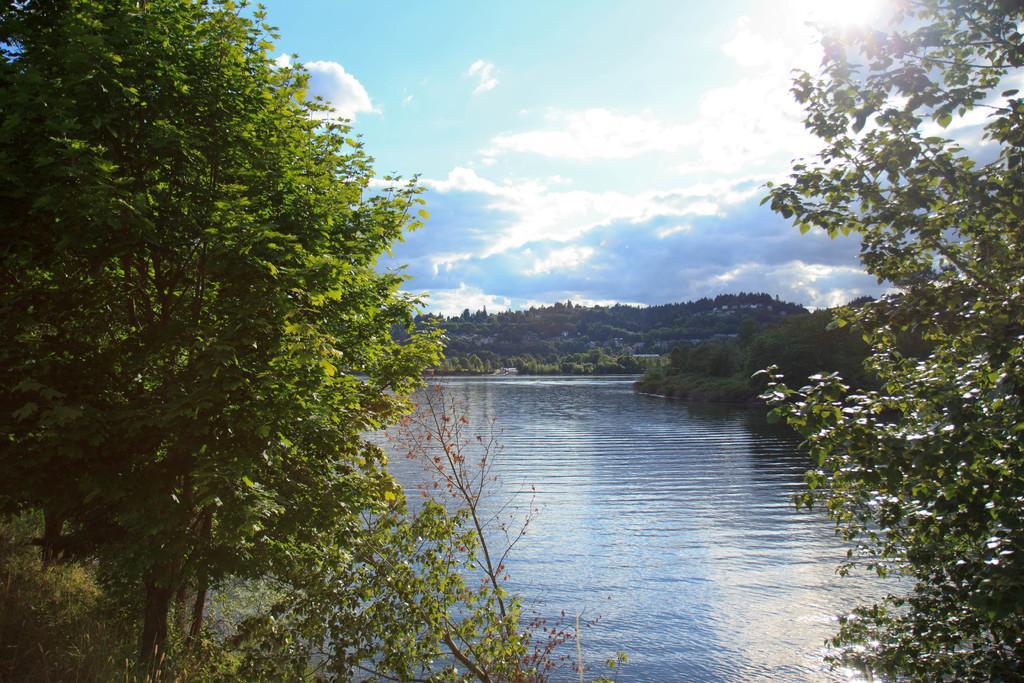Describe this image in one or two sentences. In the center of the image there is a lake. On the left side of the image there are trees and plants. On the right side there is a tree. In the background there are many trees, buildings, sky and clouds. 